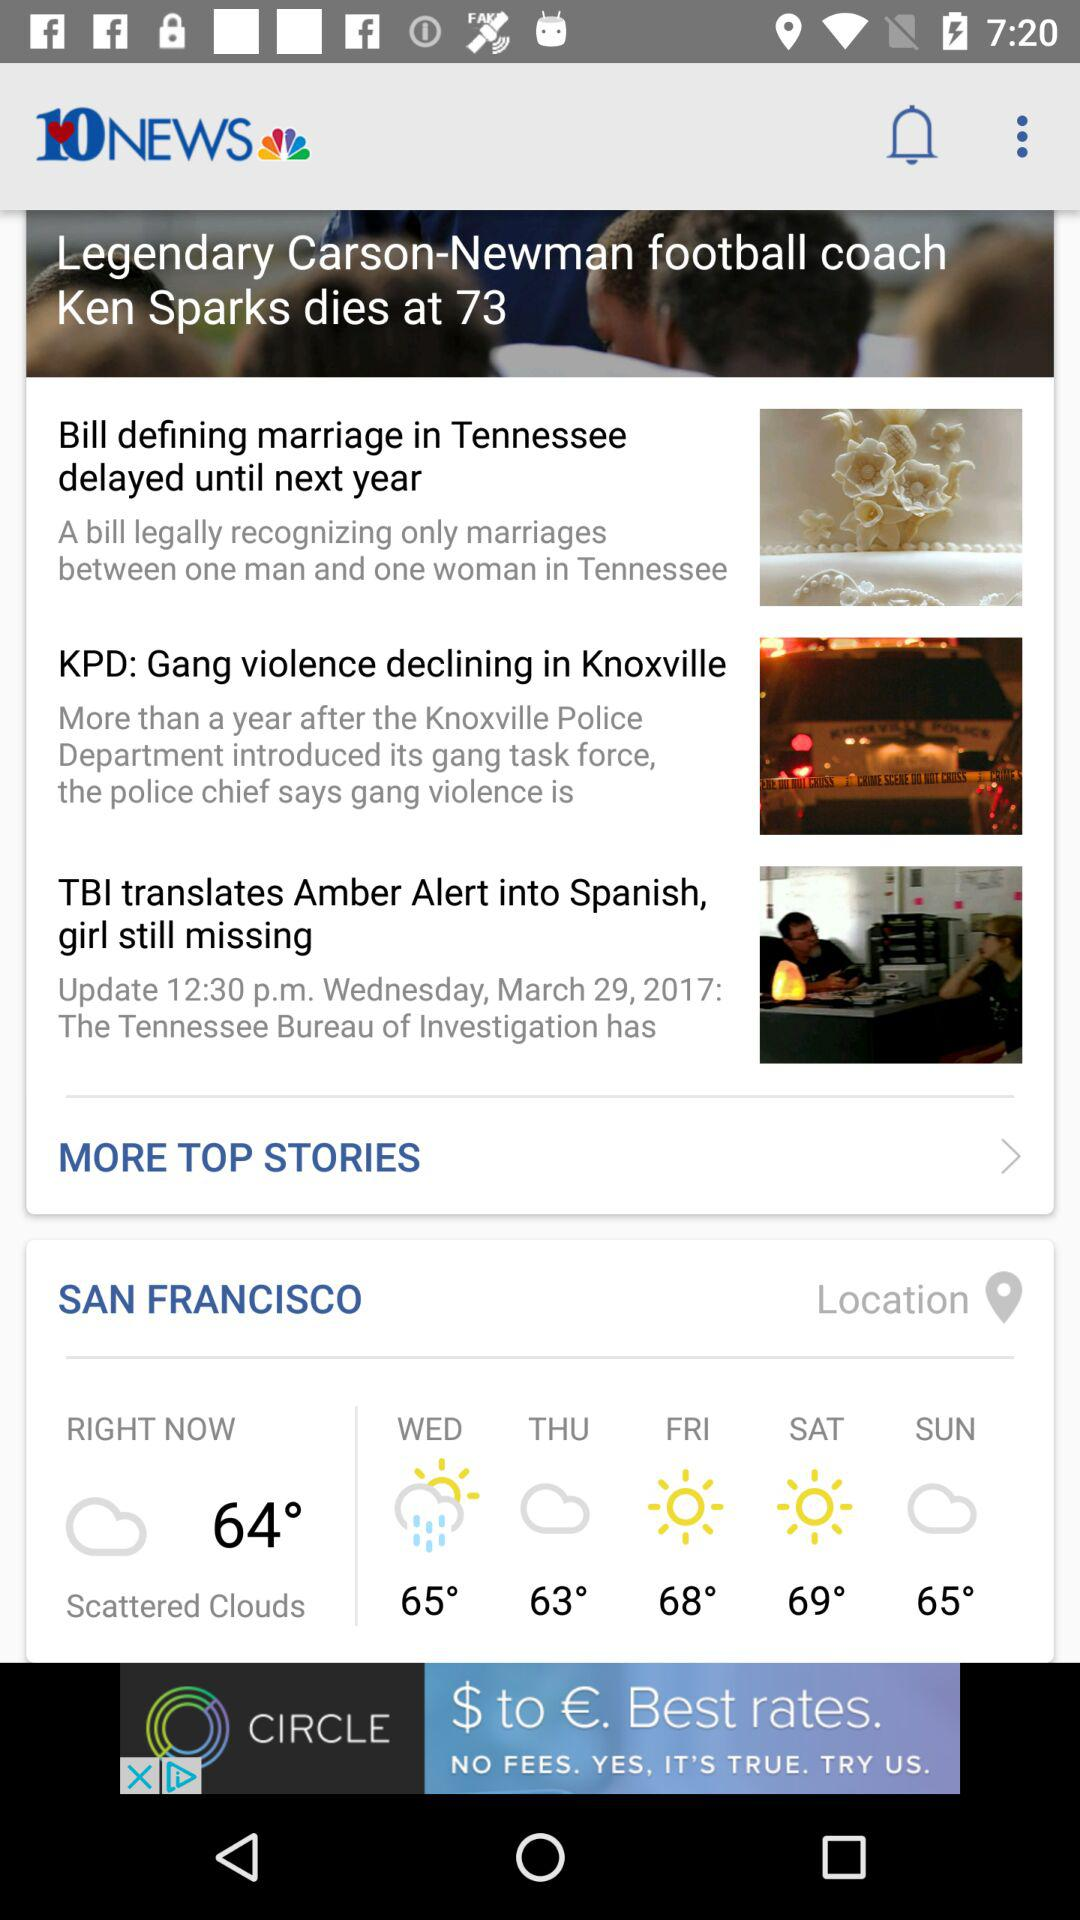What is the news channel name? The news channel name is 10NEWS. 